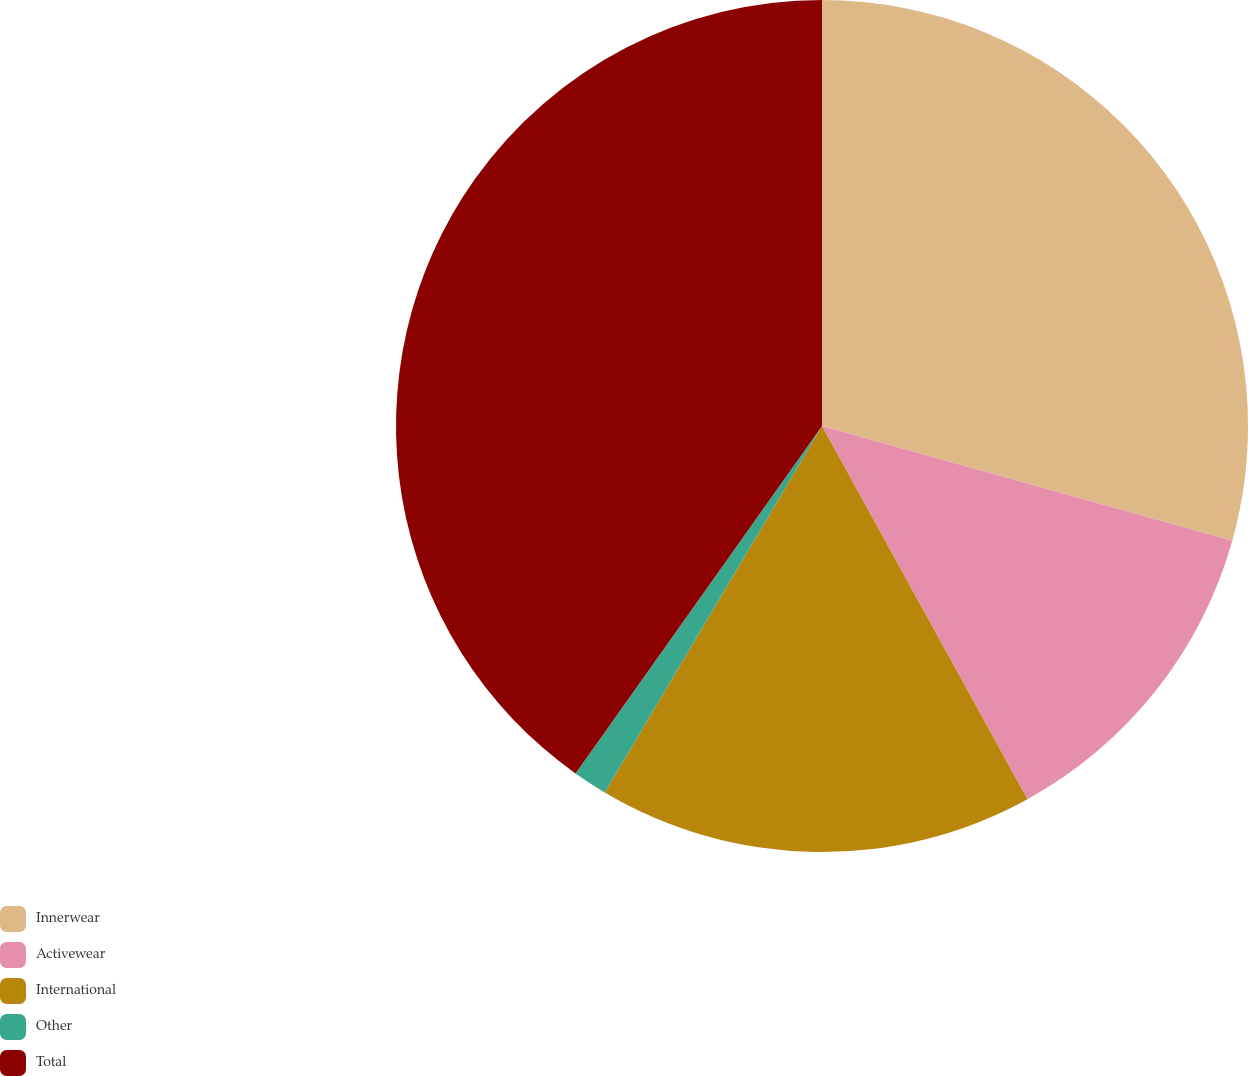Convert chart. <chart><loc_0><loc_0><loc_500><loc_500><pie_chart><fcel>Innerwear<fcel>Activewear<fcel>International<fcel>Other<fcel>Total<nl><fcel>29.34%<fcel>12.65%<fcel>16.53%<fcel>1.3%<fcel>40.18%<nl></chart> 